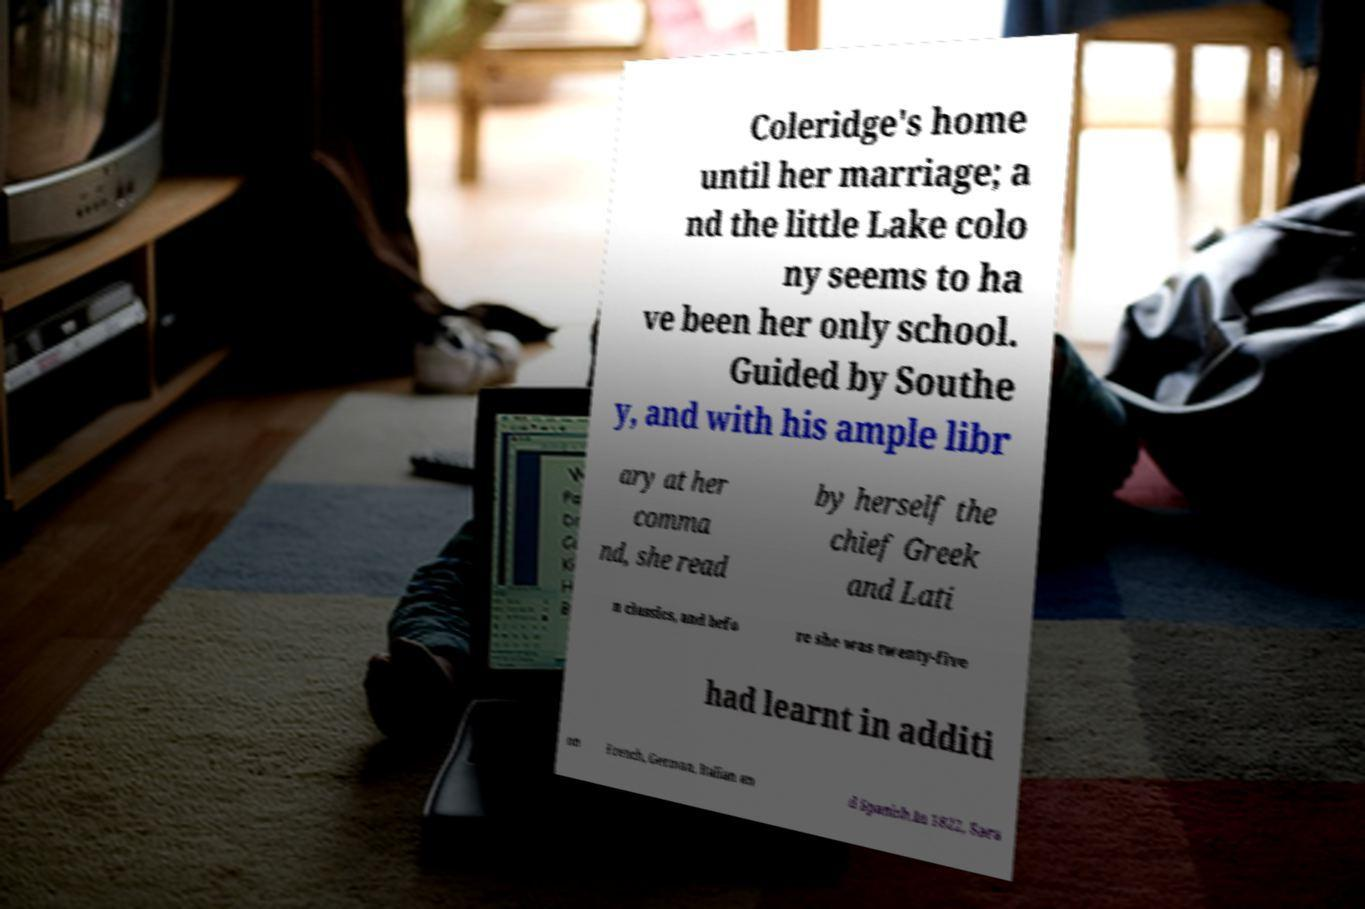I need the written content from this picture converted into text. Can you do that? Coleridge's home until her marriage; a nd the little Lake colo ny seems to ha ve been her only school. Guided by Southe y, and with his ample libr ary at her comma nd, she read by herself the chief Greek and Lati n classics, and befo re she was twenty-five had learnt in additi on French, German, Italian an d Spanish.In 1822, Sara 